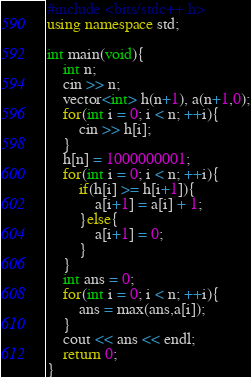<code> <loc_0><loc_0><loc_500><loc_500><_C++_>#include <bits/stdc++.h>
using namespace std;

int main(void){
	int n;
	cin >> n;
	vector<int> h(n+1), a(n+1,0);
	for(int i = 0; i < n; ++i){
		cin >> h[i];
	}
	h[n] = 1000000001;
	for(int i = 0; i < n; ++i){
		if(h[i] >= h[i+1]){
			a[i+1] = a[i] + 1;
		}else{
			a[i+1] = 0;
		}
	}
	int ans = 0;
	for(int i = 0; i < n; ++i){
		ans = max(ans,a[i]);
	}
	cout << ans << endl;
	return 0;
}
</code> 